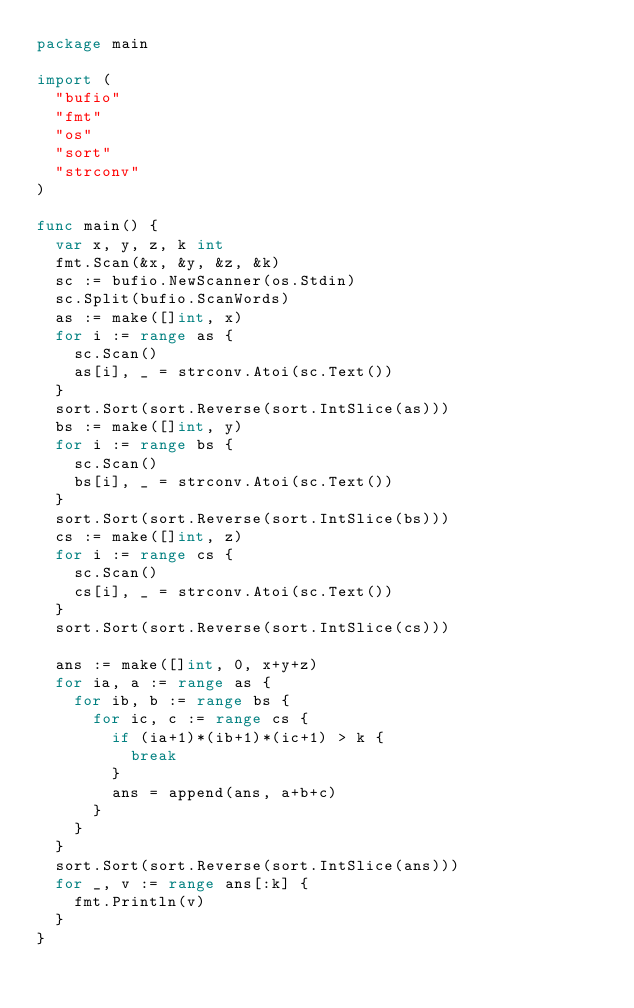<code> <loc_0><loc_0><loc_500><loc_500><_Go_>package main

import (
	"bufio"
	"fmt"
	"os"
	"sort"
	"strconv"
)

func main() {
	var x, y, z, k int
	fmt.Scan(&x, &y, &z, &k)
	sc := bufio.NewScanner(os.Stdin)
	sc.Split(bufio.ScanWords)
	as := make([]int, x)
	for i := range as {
		sc.Scan()
		as[i], _ = strconv.Atoi(sc.Text())
	}
	sort.Sort(sort.Reverse(sort.IntSlice(as)))
	bs := make([]int, y)
	for i := range bs {
		sc.Scan()
		bs[i], _ = strconv.Atoi(sc.Text())
	}
	sort.Sort(sort.Reverse(sort.IntSlice(bs)))
	cs := make([]int, z)
	for i := range cs {
		sc.Scan()
		cs[i], _ = strconv.Atoi(sc.Text())
	}
	sort.Sort(sort.Reverse(sort.IntSlice(cs)))

	ans := make([]int, 0, x+y+z)
	for ia, a := range as {
		for ib, b := range bs {
			for ic, c := range cs {
				if (ia+1)*(ib+1)*(ic+1) > k {
					break
				}
				ans = append(ans, a+b+c)
			}
		}
	}
	sort.Sort(sort.Reverse(sort.IntSlice(ans)))
	for _, v := range ans[:k] {
		fmt.Println(v)
	}
}
</code> 